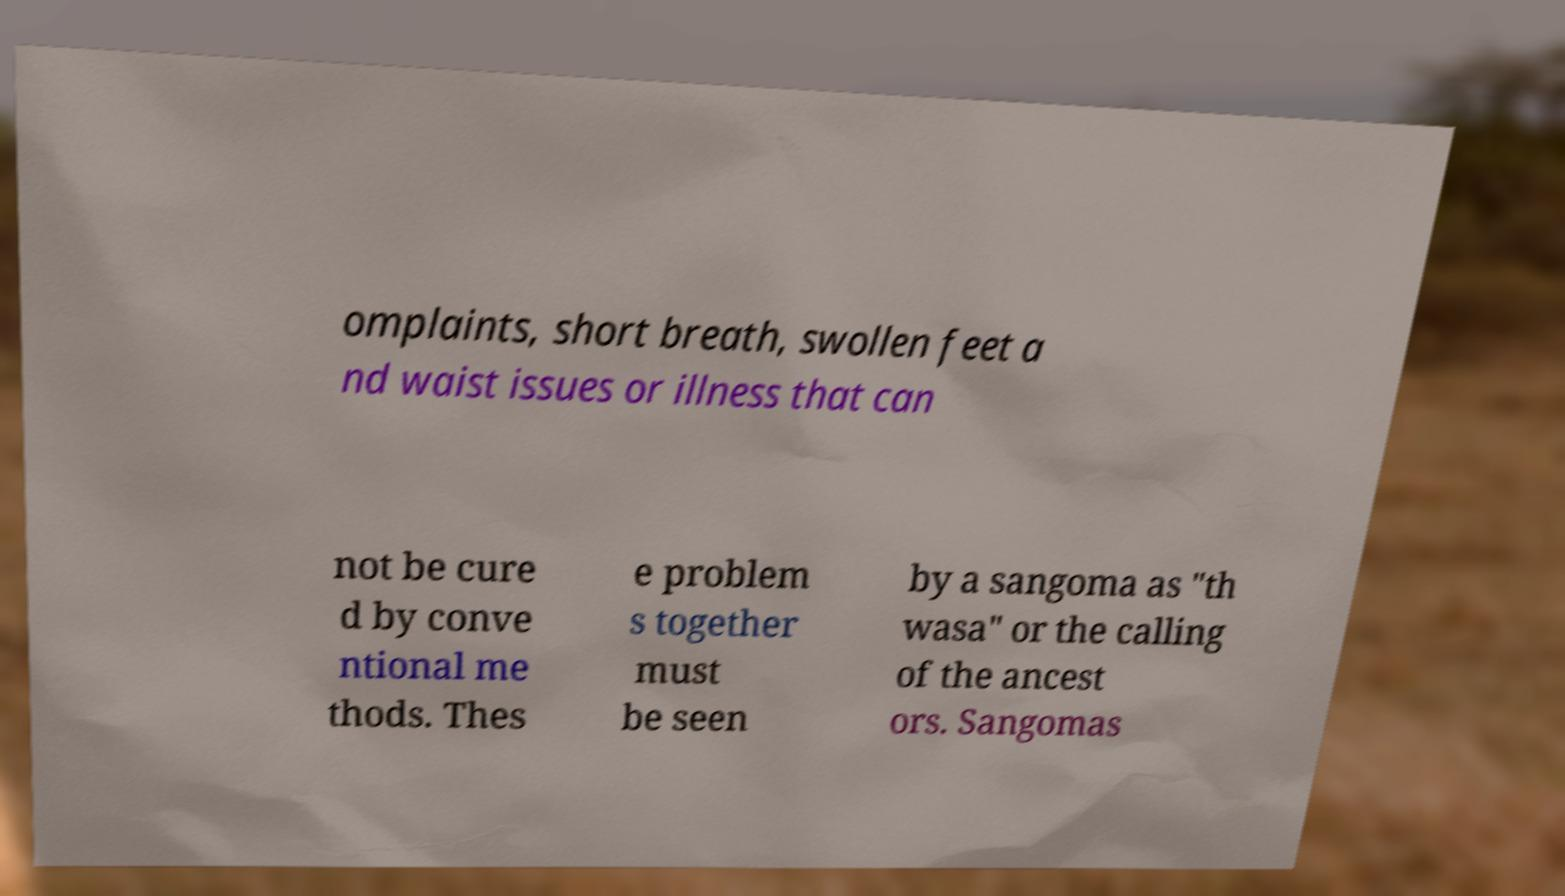Please identify and transcribe the text found in this image. omplaints, short breath, swollen feet a nd waist issues or illness that can not be cure d by conve ntional me thods. Thes e problem s together must be seen by a sangoma as "th wasa" or the calling of the ancest ors. Sangomas 